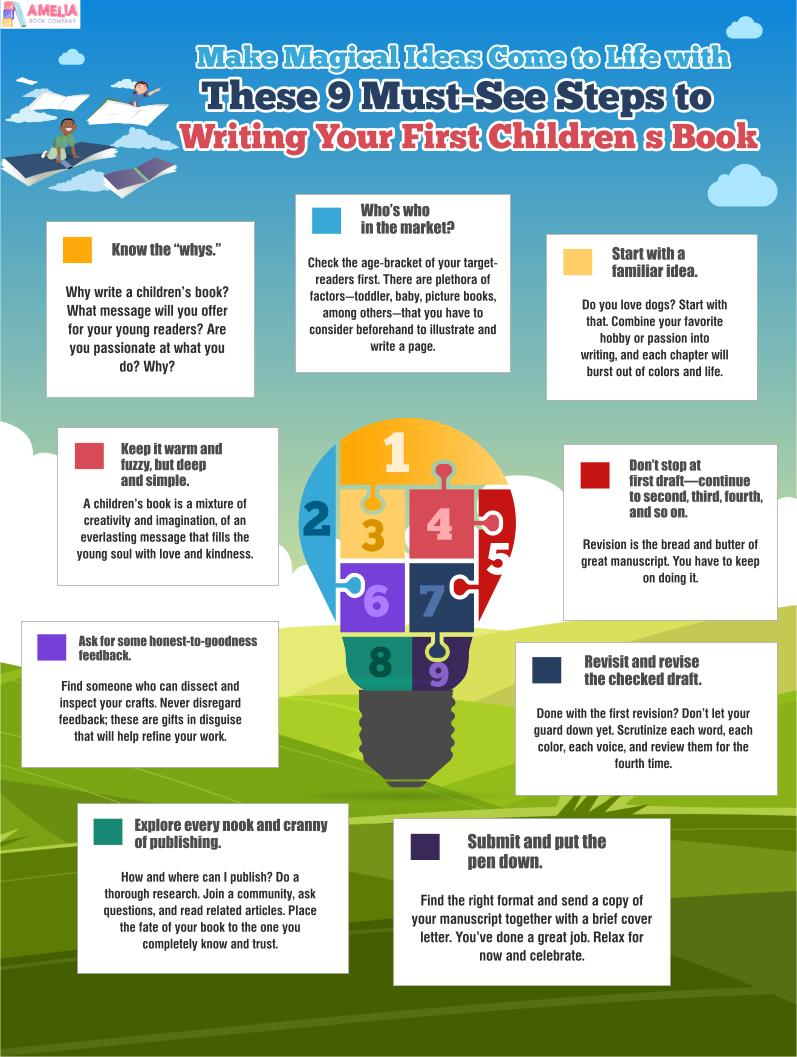Give some essential details in this illustration. The color of the square that represents step 3, honest feedback, is violet. The step represented by the blue square is: "Who's who in the market?". This step focuses on understanding the key players in the market and their positions, in order to better navigate the market and make informed decisions. 